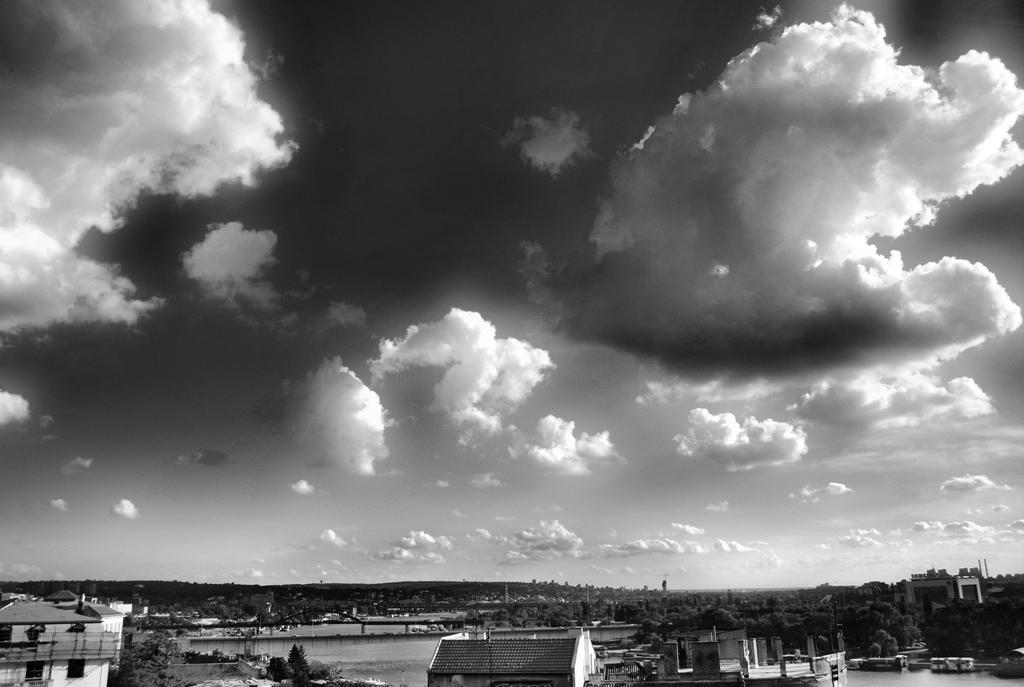What types of structures are present in the image? There are buildings and houses in the image. What natural elements can be seen in the image? There are trees and water visible in the image. What man-made structure is present in the image? There is a bridge in the image. What is visible at the bottom of the image? Water is visible at the bottom of the image. What can be seen in the background of the image? The sky is visible in the background of the image. What is the condition of the sky in the image? The sky has clouds in the image. What song is being played by the dogs in the image? There are no dogs or songs present in the image. How does the steam escape from the water in the image? There is no steam present in the image. 